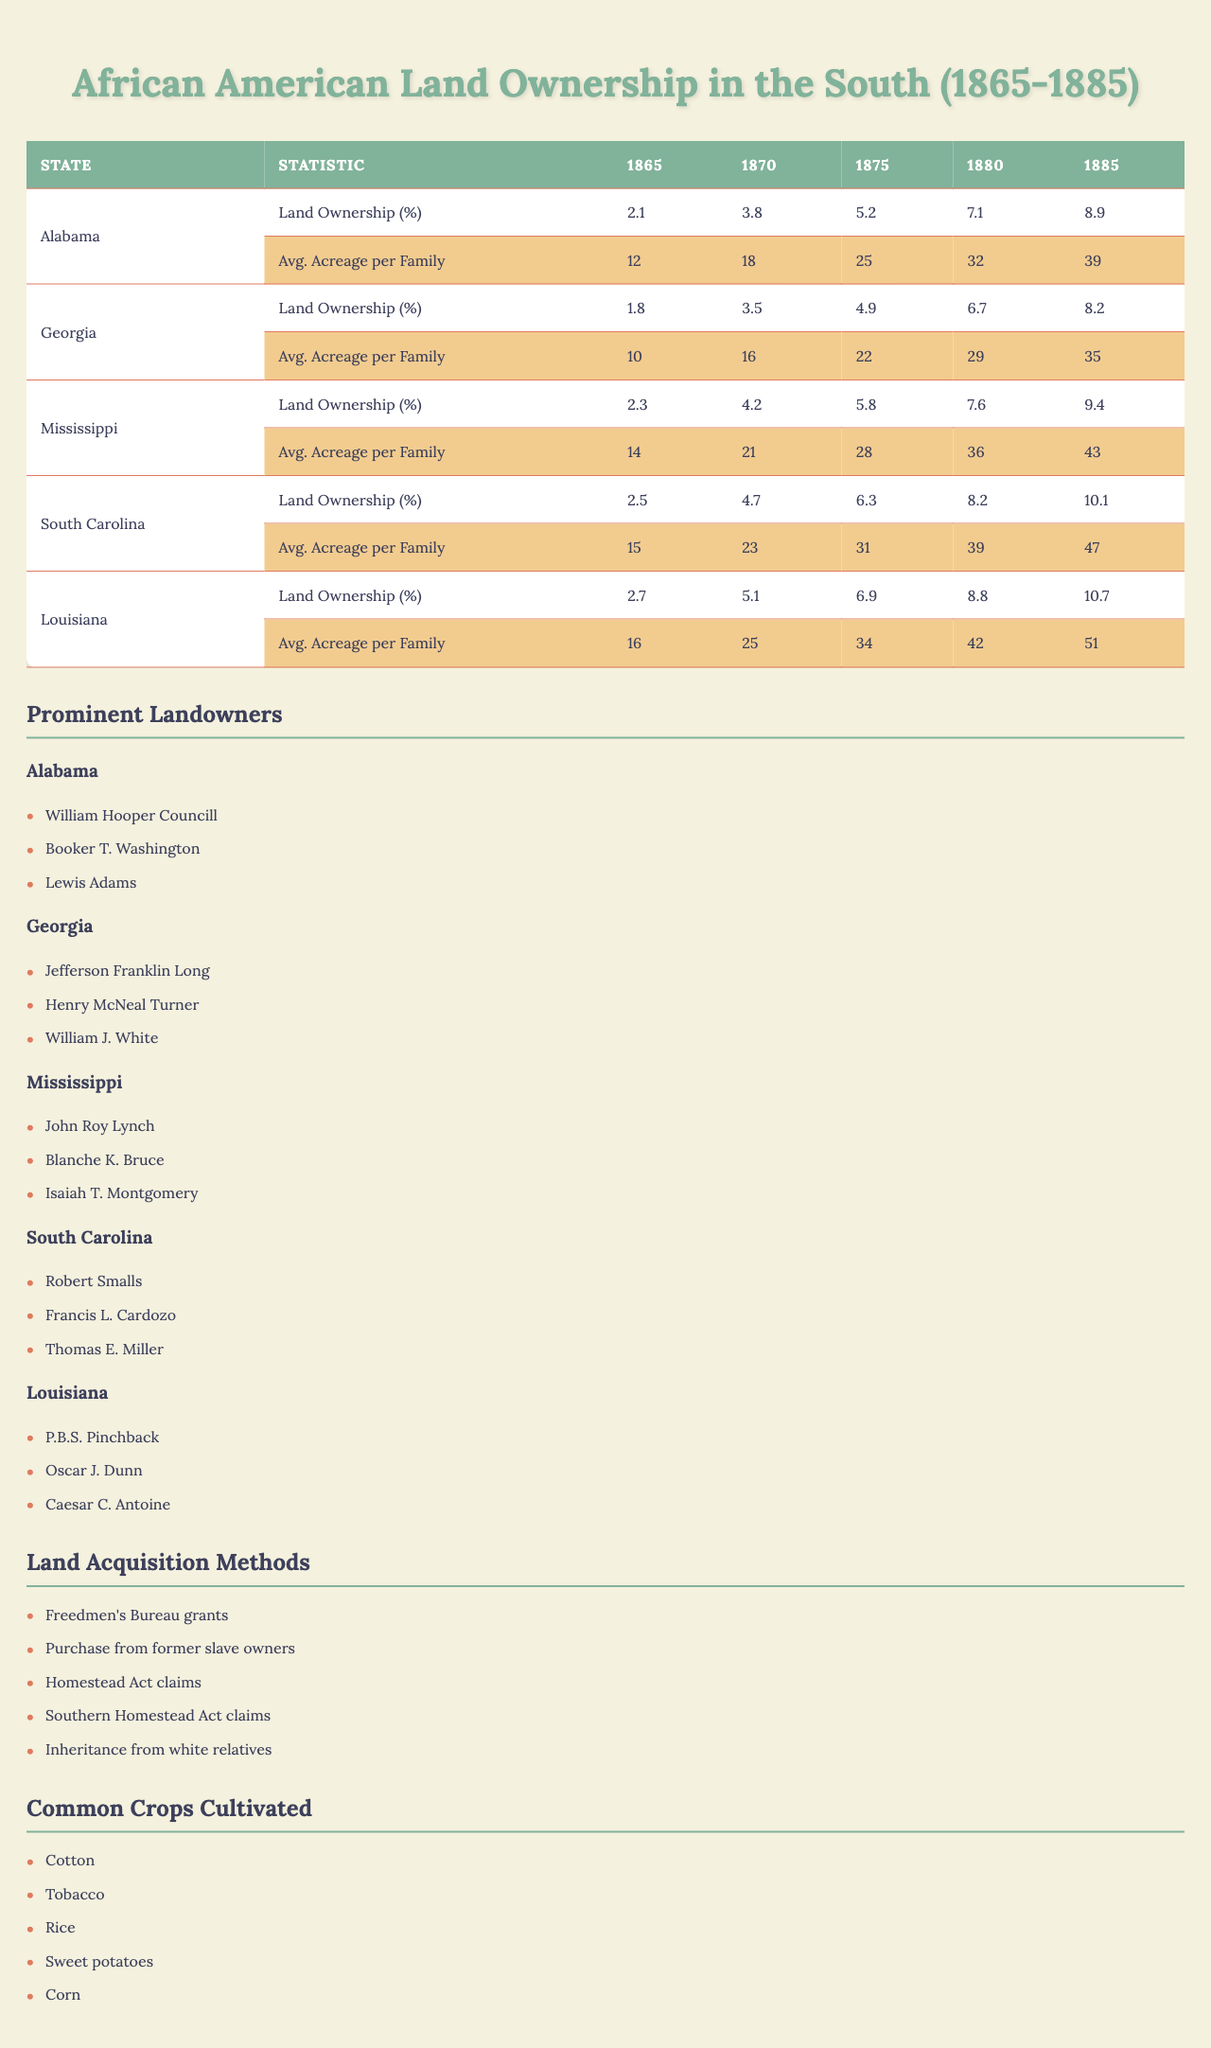What was the land ownership percentage for African American families in Alabama in 1885? In the table under Alabama's land ownership percentage for the year 1885, the value is provided as 8.9%.
Answer: 8.9% What is the average acreage per family in Mississippi for the year 1875? Looking at the average acreage per family row for Mississippi in the year 1875, the value is 28 acres.
Answer: 28 Which state had the highest percentage of land ownership for African American families in 1880? By comparing the percentages of land ownership across the states for 1880, South Carolina has the highest at 8.2%.
Answer: South Carolina How much did land ownership increase in Louisiana from 1870 to 1885? The land ownership percentage in Louisiana for 1870 was 5.1%, and for 1885 it was 10.7%. To find the increase, subtract 5.1 from 10.7: 10.7 - 5.1 = 5.6%.
Answer: 5.6% Which two prominent landowners are associated with Georgia? The table lists three prominent landowners from Georgia: Jefferson Franklin Long and Henry McNeal Turner. Therefore, the correct answer includes these two figures.
Answer: Jefferson Franklin Long, Henry McNeal Turner What was the average increase in land ownership percentage for South Carolina from 1865 to 1885? The ownership percentage for South Carolina in 1865 was 2.5%, and in 1885 it was 10.1%. The increase is calculated as 10.1 - 2.5 = 7.6%. There are four intervals (1865 to 1870, 1870 to 1875, 1875 to 1880, 1880 to 1885), so we divide the total increase by 4: 7.6% / 4 = 1.9% average increase per interval.
Answer: 1.9% Did the average acreage per family grow in all states from 1865 to 1885? By looking at the average acreage per family over the years, all values increase from 1865 to 1885 for each state listed in the table. Thus, the answer is yes.
Answer: Yes How does the average acreage per family in South Carolina compare to Louisiana in 1880? In 1880, South Carolina had an average acreage per family of 39, whereas Louisiana had 42. Comparing these two values shows that Louisiana had a higher average.
Answer: Louisiana had a higher average Which state shows the least growth in land ownership percentage from 1865 to 1885? By calculating the total growth in land ownership from the percentages provided for each state, Alabama shows a growth from 2.1% to 8.9%, totaling an increase of 6.8%, which is the smallest compared to the others.
Answer: Alabama 